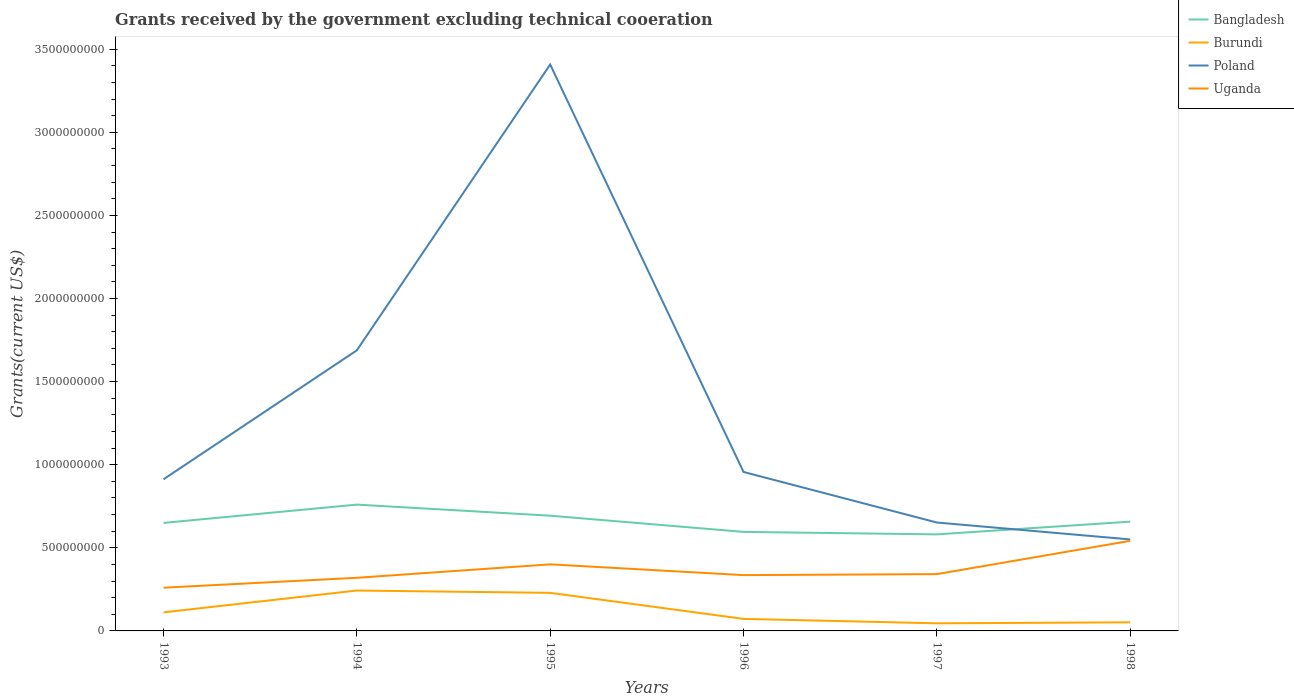Does the line corresponding to Burundi intersect with the line corresponding to Bangladesh?
Your answer should be compact. No. Is the number of lines equal to the number of legend labels?
Give a very brief answer. Yes. Across all years, what is the maximum total grants received by the government in Bangladesh?
Your answer should be very brief. 5.81e+08. What is the total total grants received by the government in Bangladesh in the graph?
Your answer should be very brief. 1.02e+08. What is the difference between the highest and the second highest total grants received by the government in Bangladesh?
Offer a terse response. 1.79e+08. How many years are there in the graph?
Offer a terse response. 6. What is the difference between two consecutive major ticks on the Y-axis?
Give a very brief answer. 5.00e+08. Are the values on the major ticks of Y-axis written in scientific E-notation?
Ensure brevity in your answer.  No. Does the graph contain grids?
Give a very brief answer. No. Where does the legend appear in the graph?
Offer a terse response. Top right. How are the legend labels stacked?
Your answer should be very brief. Vertical. What is the title of the graph?
Give a very brief answer. Grants received by the government excluding technical cooeration. Does "Grenada" appear as one of the legend labels in the graph?
Ensure brevity in your answer.  No. What is the label or title of the X-axis?
Offer a terse response. Years. What is the label or title of the Y-axis?
Make the answer very short. Grants(current US$). What is the Grants(current US$) in Bangladesh in 1993?
Your answer should be compact. 6.50e+08. What is the Grants(current US$) of Burundi in 1993?
Keep it short and to the point. 1.12e+08. What is the Grants(current US$) in Poland in 1993?
Provide a succinct answer. 9.12e+08. What is the Grants(current US$) in Uganda in 1993?
Keep it short and to the point. 2.60e+08. What is the Grants(current US$) in Bangladesh in 1994?
Provide a succinct answer. 7.60e+08. What is the Grants(current US$) of Burundi in 1994?
Your answer should be compact. 2.43e+08. What is the Grants(current US$) in Poland in 1994?
Provide a succinct answer. 1.69e+09. What is the Grants(current US$) in Uganda in 1994?
Your response must be concise. 3.20e+08. What is the Grants(current US$) of Bangladesh in 1995?
Offer a terse response. 6.93e+08. What is the Grants(current US$) of Burundi in 1995?
Offer a very short reply. 2.29e+08. What is the Grants(current US$) in Poland in 1995?
Keep it short and to the point. 3.41e+09. What is the Grants(current US$) in Uganda in 1995?
Your answer should be compact. 4.01e+08. What is the Grants(current US$) of Bangladesh in 1996?
Keep it short and to the point. 5.96e+08. What is the Grants(current US$) of Burundi in 1996?
Your answer should be compact. 7.24e+07. What is the Grants(current US$) in Poland in 1996?
Provide a succinct answer. 9.56e+08. What is the Grants(current US$) of Uganda in 1996?
Provide a short and direct response. 3.36e+08. What is the Grants(current US$) of Bangladesh in 1997?
Provide a succinct answer. 5.81e+08. What is the Grants(current US$) of Burundi in 1997?
Your answer should be very brief. 4.58e+07. What is the Grants(current US$) of Poland in 1997?
Offer a very short reply. 6.52e+08. What is the Grants(current US$) in Uganda in 1997?
Your answer should be compact. 3.42e+08. What is the Grants(current US$) of Bangladesh in 1998?
Offer a very short reply. 6.58e+08. What is the Grants(current US$) in Burundi in 1998?
Offer a terse response. 5.17e+07. What is the Grants(current US$) in Poland in 1998?
Keep it short and to the point. 5.50e+08. What is the Grants(current US$) in Uganda in 1998?
Provide a short and direct response. 5.42e+08. Across all years, what is the maximum Grants(current US$) of Bangladesh?
Your answer should be compact. 7.60e+08. Across all years, what is the maximum Grants(current US$) of Burundi?
Your answer should be very brief. 2.43e+08. Across all years, what is the maximum Grants(current US$) of Poland?
Ensure brevity in your answer.  3.41e+09. Across all years, what is the maximum Grants(current US$) in Uganda?
Your answer should be very brief. 5.42e+08. Across all years, what is the minimum Grants(current US$) of Bangladesh?
Your answer should be very brief. 5.81e+08. Across all years, what is the minimum Grants(current US$) of Burundi?
Offer a very short reply. 4.58e+07. Across all years, what is the minimum Grants(current US$) in Poland?
Your answer should be compact. 5.50e+08. Across all years, what is the minimum Grants(current US$) in Uganda?
Offer a very short reply. 2.60e+08. What is the total Grants(current US$) of Bangladesh in the graph?
Keep it short and to the point. 3.94e+09. What is the total Grants(current US$) of Burundi in the graph?
Offer a terse response. 7.54e+08. What is the total Grants(current US$) in Poland in the graph?
Keep it short and to the point. 8.17e+09. What is the total Grants(current US$) of Uganda in the graph?
Ensure brevity in your answer.  2.20e+09. What is the difference between the Grants(current US$) in Bangladesh in 1993 and that in 1994?
Offer a very short reply. -1.10e+08. What is the difference between the Grants(current US$) of Burundi in 1993 and that in 1994?
Your answer should be compact. -1.31e+08. What is the difference between the Grants(current US$) of Poland in 1993 and that in 1994?
Your answer should be very brief. -7.76e+08. What is the difference between the Grants(current US$) in Uganda in 1993 and that in 1994?
Offer a very short reply. -5.96e+07. What is the difference between the Grants(current US$) in Bangladesh in 1993 and that in 1995?
Keep it short and to the point. -4.34e+07. What is the difference between the Grants(current US$) in Burundi in 1993 and that in 1995?
Ensure brevity in your answer.  -1.17e+08. What is the difference between the Grants(current US$) in Poland in 1993 and that in 1995?
Your answer should be very brief. -2.50e+09. What is the difference between the Grants(current US$) of Uganda in 1993 and that in 1995?
Provide a short and direct response. -1.40e+08. What is the difference between the Grants(current US$) in Bangladesh in 1993 and that in 1996?
Your response must be concise. 5.40e+07. What is the difference between the Grants(current US$) of Burundi in 1993 and that in 1996?
Offer a very short reply. 3.93e+07. What is the difference between the Grants(current US$) in Poland in 1993 and that in 1996?
Offer a terse response. -4.42e+07. What is the difference between the Grants(current US$) in Uganda in 1993 and that in 1996?
Provide a succinct answer. -7.58e+07. What is the difference between the Grants(current US$) of Bangladesh in 1993 and that in 1997?
Your answer should be compact. 6.90e+07. What is the difference between the Grants(current US$) of Burundi in 1993 and that in 1997?
Provide a succinct answer. 6.59e+07. What is the difference between the Grants(current US$) of Poland in 1993 and that in 1997?
Your answer should be compact. 2.60e+08. What is the difference between the Grants(current US$) of Uganda in 1993 and that in 1997?
Give a very brief answer. -8.17e+07. What is the difference between the Grants(current US$) of Bangladesh in 1993 and that in 1998?
Ensure brevity in your answer.  -7.64e+06. What is the difference between the Grants(current US$) in Burundi in 1993 and that in 1998?
Make the answer very short. 6.00e+07. What is the difference between the Grants(current US$) in Poland in 1993 and that in 1998?
Provide a short and direct response. 3.62e+08. What is the difference between the Grants(current US$) in Uganda in 1993 and that in 1998?
Provide a short and direct response. -2.82e+08. What is the difference between the Grants(current US$) in Bangladesh in 1994 and that in 1995?
Provide a succinct answer. 6.66e+07. What is the difference between the Grants(current US$) in Burundi in 1994 and that in 1995?
Your answer should be compact. 1.40e+07. What is the difference between the Grants(current US$) in Poland in 1994 and that in 1995?
Offer a terse response. -1.72e+09. What is the difference between the Grants(current US$) in Uganda in 1994 and that in 1995?
Offer a very short reply. -8.09e+07. What is the difference between the Grants(current US$) in Bangladesh in 1994 and that in 1996?
Provide a succinct answer. 1.64e+08. What is the difference between the Grants(current US$) in Burundi in 1994 and that in 1996?
Your response must be concise. 1.71e+08. What is the difference between the Grants(current US$) in Poland in 1994 and that in 1996?
Provide a succinct answer. 7.32e+08. What is the difference between the Grants(current US$) of Uganda in 1994 and that in 1996?
Offer a terse response. -1.62e+07. What is the difference between the Grants(current US$) of Bangladesh in 1994 and that in 1997?
Give a very brief answer. 1.79e+08. What is the difference between the Grants(current US$) of Burundi in 1994 and that in 1997?
Offer a very short reply. 1.97e+08. What is the difference between the Grants(current US$) in Poland in 1994 and that in 1997?
Your answer should be very brief. 1.04e+09. What is the difference between the Grants(current US$) of Uganda in 1994 and that in 1997?
Make the answer very short. -2.21e+07. What is the difference between the Grants(current US$) in Bangladesh in 1994 and that in 1998?
Your answer should be compact. 1.02e+08. What is the difference between the Grants(current US$) of Burundi in 1994 and that in 1998?
Make the answer very short. 1.91e+08. What is the difference between the Grants(current US$) of Poland in 1994 and that in 1998?
Your response must be concise. 1.14e+09. What is the difference between the Grants(current US$) of Uganda in 1994 and that in 1998?
Keep it short and to the point. -2.22e+08. What is the difference between the Grants(current US$) in Bangladesh in 1995 and that in 1996?
Keep it short and to the point. 9.74e+07. What is the difference between the Grants(current US$) of Burundi in 1995 and that in 1996?
Offer a terse response. 1.57e+08. What is the difference between the Grants(current US$) of Poland in 1995 and that in 1996?
Your answer should be very brief. 2.45e+09. What is the difference between the Grants(current US$) of Uganda in 1995 and that in 1996?
Keep it short and to the point. 6.47e+07. What is the difference between the Grants(current US$) in Bangladesh in 1995 and that in 1997?
Your answer should be very brief. 1.12e+08. What is the difference between the Grants(current US$) in Burundi in 1995 and that in 1997?
Provide a short and direct response. 1.83e+08. What is the difference between the Grants(current US$) in Poland in 1995 and that in 1997?
Your answer should be compact. 2.76e+09. What is the difference between the Grants(current US$) of Uganda in 1995 and that in 1997?
Your answer should be compact. 5.88e+07. What is the difference between the Grants(current US$) in Bangladesh in 1995 and that in 1998?
Offer a terse response. 3.58e+07. What is the difference between the Grants(current US$) of Burundi in 1995 and that in 1998?
Offer a terse response. 1.77e+08. What is the difference between the Grants(current US$) of Poland in 1995 and that in 1998?
Your answer should be very brief. 2.86e+09. What is the difference between the Grants(current US$) of Uganda in 1995 and that in 1998?
Your answer should be compact. -1.42e+08. What is the difference between the Grants(current US$) of Bangladesh in 1996 and that in 1997?
Make the answer very short. 1.50e+07. What is the difference between the Grants(current US$) of Burundi in 1996 and that in 1997?
Provide a succinct answer. 2.66e+07. What is the difference between the Grants(current US$) in Poland in 1996 and that in 1997?
Your response must be concise. 3.04e+08. What is the difference between the Grants(current US$) in Uganda in 1996 and that in 1997?
Offer a very short reply. -5.92e+06. What is the difference between the Grants(current US$) of Bangladesh in 1996 and that in 1998?
Your response must be concise. -6.17e+07. What is the difference between the Grants(current US$) of Burundi in 1996 and that in 1998?
Offer a very short reply. 2.07e+07. What is the difference between the Grants(current US$) in Poland in 1996 and that in 1998?
Ensure brevity in your answer.  4.06e+08. What is the difference between the Grants(current US$) in Uganda in 1996 and that in 1998?
Keep it short and to the point. -2.06e+08. What is the difference between the Grants(current US$) of Bangladesh in 1997 and that in 1998?
Offer a terse response. -7.66e+07. What is the difference between the Grants(current US$) of Burundi in 1997 and that in 1998?
Your answer should be very brief. -5.87e+06. What is the difference between the Grants(current US$) in Poland in 1997 and that in 1998?
Give a very brief answer. 1.02e+08. What is the difference between the Grants(current US$) in Uganda in 1997 and that in 1998?
Provide a short and direct response. -2.00e+08. What is the difference between the Grants(current US$) of Bangladesh in 1993 and the Grants(current US$) of Burundi in 1994?
Ensure brevity in your answer.  4.07e+08. What is the difference between the Grants(current US$) of Bangladesh in 1993 and the Grants(current US$) of Poland in 1994?
Ensure brevity in your answer.  -1.04e+09. What is the difference between the Grants(current US$) in Bangladesh in 1993 and the Grants(current US$) in Uganda in 1994?
Keep it short and to the point. 3.30e+08. What is the difference between the Grants(current US$) of Burundi in 1993 and the Grants(current US$) of Poland in 1994?
Ensure brevity in your answer.  -1.58e+09. What is the difference between the Grants(current US$) of Burundi in 1993 and the Grants(current US$) of Uganda in 1994?
Your answer should be very brief. -2.08e+08. What is the difference between the Grants(current US$) of Poland in 1993 and the Grants(current US$) of Uganda in 1994?
Your answer should be very brief. 5.93e+08. What is the difference between the Grants(current US$) in Bangladesh in 1993 and the Grants(current US$) in Burundi in 1995?
Make the answer very short. 4.21e+08. What is the difference between the Grants(current US$) of Bangladesh in 1993 and the Grants(current US$) of Poland in 1995?
Provide a short and direct response. -2.76e+09. What is the difference between the Grants(current US$) of Bangladesh in 1993 and the Grants(current US$) of Uganda in 1995?
Your response must be concise. 2.49e+08. What is the difference between the Grants(current US$) of Burundi in 1993 and the Grants(current US$) of Poland in 1995?
Your response must be concise. -3.30e+09. What is the difference between the Grants(current US$) of Burundi in 1993 and the Grants(current US$) of Uganda in 1995?
Your answer should be compact. -2.89e+08. What is the difference between the Grants(current US$) in Poland in 1993 and the Grants(current US$) in Uganda in 1995?
Your answer should be compact. 5.12e+08. What is the difference between the Grants(current US$) in Bangladesh in 1993 and the Grants(current US$) in Burundi in 1996?
Offer a terse response. 5.78e+08. What is the difference between the Grants(current US$) in Bangladesh in 1993 and the Grants(current US$) in Poland in 1996?
Provide a short and direct response. -3.07e+08. What is the difference between the Grants(current US$) in Bangladesh in 1993 and the Grants(current US$) in Uganda in 1996?
Your response must be concise. 3.14e+08. What is the difference between the Grants(current US$) of Burundi in 1993 and the Grants(current US$) of Poland in 1996?
Your response must be concise. -8.45e+08. What is the difference between the Grants(current US$) of Burundi in 1993 and the Grants(current US$) of Uganda in 1996?
Give a very brief answer. -2.24e+08. What is the difference between the Grants(current US$) of Poland in 1993 and the Grants(current US$) of Uganda in 1996?
Provide a short and direct response. 5.76e+08. What is the difference between the Grants(current US$) of Bangladesh in 1993 and the Grants(current US$) of Burundi in 1997?
Provide a short and direct response. 6.04e+08. What is the difference between the Grants(current US$) in Bangladesh in 1993 and the Grants(current US$) in Poland in 1997?
Provide a short and direct response. -2.29e+06. What is the difference between the Grants(current US$) in Bangladesh in 1993 and the Grants(current US$) in Uganda in 1997?
Give a very brief answer. 3.08e+08. What is the difference between the Grants(current US$) in Burundi in 1993 and the Grants(current US$) in Poland in 1997?
Offer a very short reply. -5.40e+08. What is the difference between the Grants(current US$) of Burundi in 1993 and the Grants(current US$) of Uganda in 1997?
Offer a very short reply. -2.30e+08. What is the difference between the Grants(current US$) of Poland in 1993 and the Grants(current US$) of Uganda in 1997?
Your answer should be very brief. 5.70e+08. What is the difference between the Grants(current US$) in Bangladesh in 1993 and the Grants(current US$) in Burundi in 1998?
Provide a succinct answer. 5.98e+08. What is the difference between the Grants(current US$) in Bangladesh in 1993 and the Grants(current US$) in Poland in 1998?
Offer a terse response. 9.95e+07. What is the difference between the Grants(current US$) in Bangladesh in 1993 and the Grants(current US$) in Uganda in 1998?
Your answer should be compact. 1.08e+08. What is the difference between the Grants(current US$) in Burundi in 1993 and the Grants(current US$) in Poland in 1998?
Provide a succinct answer. -4.39e+08. What is the difference between the Grants(current US$) of Burundi in 1993 and the Grants(current US$) of Uganda in 1998?
Give a very brief answer. -4.30e+08. What is the difference between the Grants(current US$) in Poland in 1993 and the Grants(current US$) in Uganda in 1998?
Provide a succinct answer. 3.70e+08. What is the difference between the Grants(current US$) of Bangladesh in 1994 and the Grants(current US$) of Burundi in 1995?
Give a very brief answer. 5.31e+08. What is the difference between the Grants(current US$) of Bangladesh in 1994 and the Grants(current US$) of Poland in 1995?
Offer a very short reply. -2.65e+09. What is the difference between the Grants(current US$) of Bangladesh in 1994 and the Grants(current US$) of Uganda in 1995?
Your answer should be compact. 3.59e+08. What is the difference between the Grants(current US$) of Burundi in 1994 and the Grants(current US$) of Poland in 1995?
Offer a very short reply. -3.16e+09. What is the difference between the Grants(current US$) in Burundi in 1994 and the Grants(current US$) in Uganda in 1995?
Your response must be concise. -1.57e+08. What is the difference between the Grants(current US$) of Poland in 1994 and the Grants(current US$) of Uganda in 1995?
Make the answer very short. 1.29e+09. What is the difference between the Grants(current US$) in Bangladesh in 1994 and the Grants(current US$) in Burundi in 1996?
Your response must be concise. 6.88e+08. What is the difference between the Grants(current US$) of Bangladesh in 1994 and the Grants(current US$) of Poland in 1996?
Ensure brevity in your answer.  -1.96e+08. What is the difference between the Grants(current US$) of Bangladesh in 1994 and the Grants(current US$) of Uganda in 1996?
Keep it short and to the point. 4.24e+08. What is the difference between the Grants(current US$) in Burundi in 1994 and the Grants(current US$) in Poland in 1996?
Your response must be concise. -7.13e+08. What is the difference between the Grants(current US$) in Burundi in 1994 and the Grants(current US$) in Uganda in 1996?
Your answer should be compact. -9.28e+07. What is the difference between the Grants(current US$) in Poland in 1994 and the Grants(current US$) in Uganda in 1996?
Offer a terse response. 1.35e+09. What is the difference between the Grants(current US$) in Bangladesh in 1994 and the Grants(current US$) in Burundi in 1997?
Keep it short and to the point. 7.14e+08. What is the difference between the Grants(current US$) in Bangladesh in 1994 and the Grants(current US$) in Poland in 1997?
Your answer should be very brief. 1.08e+08. What is the difference between the Grants(current US$) in Bangladesh in 1994 and the Grants(current US$) in Uganda in 1997?
Provide a succinct answer. 4.18e+08. What is the difference between the Grants(current US$) in Burundi in 1994 and the Grants(current US$) in Poland in 1997?
Provide a short and direct response. -4.09e+08. What is the difference between the Grants(current US$) of Burundi in 1994 and the Grants(current US$) of Uganda in 1997?
Make the answer very short. -9.87e+07. What is the difference between the Grants(current US$) of Poland in 1994 and the Grants(current US$) of Uganda in 1997?
Make the answer very short. 1.35e+09. What is the difference between the Grants(current US$) of Bangladesh in 1994 and the Grants(current US$) of Burundi in 1998?
Your response must be concise. 7.08e+08. What is the difference between the Grants(current US$) in Bangladesh in 1994 and the Grants(current US$) in Poland in 1998?
Your answer should be very brief. 2.10e+08. What is the difference between the Grants(current US$) of Bangladesh in 1994 and the Grants(current US$) of Uganda in 1998?
Your answer should be very brief. 2.18e+08. What is the difference between the Grants(current US$) of Burundi in 1994 and the Grants(current US$) of Poland in 1998?
Keep it short and to the point. -3.07e+08. What is the difference between the Grants(current US$) in Burundi in 1994 and the Grants(current US$) in Uganda in 1998?
Your answer should be compact. -2.99e+08. What is the difference between the Grants(current US$) of Poland in 1994 and the Grants(current US$) of Uganda in 1998?
Give a very brief answer. 1.15e+09. What is the difference between the Grants(current US$) of Bangladesh in 1995 and the Grants(current US$) of Burundi in 1996?
Provide a short and direct response. 6.21e+08. What is the difference between the Grants(current US$) of Bangladesh in 1995 and the Grants(current US$) of Poland in 1996?
Ensure brevity in your answer.  -2.63e+08. What is the difference between the Grants(current US$) of Bangladesh in 1995 and the Grants(current US$) of Uganda in 1996?
Give a very brief answer. 3.57e+08. What is the difference between the Grants(current US$) in Burundi in 1995 and the Grants(current US$) in Poland in 1996?
Offer a terse response. -7.27e+08. What is the difference between the Grants(current US$) of Burundi in 1995 and the Grants(current US$) of Uganda in 1996?
Provide a short and direct response. -1.07e+08. What is the difference between the Grants(current US$) in Poland in 1995 and the Grants(current US$) in Uganda in 1996?
Ensure brevity in your answer.  3.07e+09. What is the difference between the Grants(current US$) in Bangladesh in 1995 and the Grants(current US$) in Burundi in 1997?
Provide a short and direct response. 6.47e+08. What is the difference between the Grants(current US$) in Bangladesh in 1995 and the Grants(current US$) in Poland in 1997?
Ensure brevity in your answer.  4.11e+07. What is the difference between the Grants(current US$) of Bangladesh in 1995 and the Grants(current US$) of Uganda in 1997?
Provide a short and direct response. 3.52e+08. What is the difference between the Grants(current US$) in Burundi in 1995 and the Grants(current US$) in Poland in 1997?
Make the answer very short. -4.23e+08. What is the difference between the Grants(current US$) of Burundi in 1995 and the Grants(current US$) of Uganda in 1997?
Offer a very short reply. -1.13e+08. What is the difference between the Grants(current US$) in Poland in 1995 and the Grants(current US$) in Uganda in 1997?
Ensure brevity in your answer.  3.07e+09. What is the difference between the Grants(current US$) in Bangladesh in 1995 and the Grants(current US$) in Burundi in 1998?
Give a very brief answer. 6.42e+08. What is the difference between the Grants(current US$) in Bangladesh in 1995 and the Grants(current US$) in Poland in 1998?
Your answer should be compact. 1.43e+08. What is the difference between the Grants(current US$) in Bangladesh in 1995 and the Grants(current US$) in Uganda in 1998?
Offer a terse response. 1.51e+08. What is the difference between the Grants(current US$) of Burundi in 1995 and the Grants(current US$) of Poland in 1998?
Your response must be concise. -3.21e+08. What is the difference between the Grants(current US$) in Burundi in 1995 and the Grants(current US$) in Uganda in 1998?
Provide a succinct answer. -3.13e+08. What is the difference between the Grants(current US$) in Poland in 1995 and the Grants(current US$) in Uganda in 1998?
Make the answer very short. 2.87e+09. What is the difference between the Grants(current US$) in Bangladesh in 1996 and the Grants(current US$) in Burundi in 1997?
Your answer should be very brief. 5.50e+08. What is the difference between the Grants(current US$) in Bangladesh in 1996 and the Grants(current US$) in Poland in 1997?
Give a very brief answer. -5.63e+07. What is the difference between the Grants(current US$) of Bangladesh in 1996 and the Grants(current US$) of Uganda in 1997?
Your answer should be very brief. 2.54e+08. What is the difference between the Grants(current US$) in Burundi in 1996 and the Grants(current US$) in Poland in 1997?
Ensure brevity in your answer.  -5.80e+08. What is the difference between the Grants(current US$) of Burundi in 1996 and the Grants(current US$) of Uganda in 1997?
Your answer should be compact. -2.69e+08. What is the difference between the Grants(current US$) in Poland in 1996 and the Grants(current US$) in Uganda in 1997?
Offer a terse response. 6.15e+08. What is the difference between the Grants(current US$) in Bangladesh in 1996 and the Grants(current US$) in Burundi in 1998?
Provide a succinct answer. 5.44e+08. What is the difference between the Grants(current US$) in Bangladesh in 1996 and the Grants(current US$) in Poland in 1998?
Offer a terse response. 4.54e+07. What is the difference between the Grants(current US$) of Bangladesh in 1996 and the Grants(current US$) of Uganda in 1998?
Provide a short and direct response. 5.38e+07. What is the difference between the Grants(current US$) in Burundi in 1996 and the Grants(current US$) in Poland in 1998?
Offer a very short reply. -4.78e+08. What is the difference between the Grants(current US$) in Burundi in 1996 and the Grants(current US$) in Uganda in 1998?
Give a very brief answer. -4.70e+08. What is the difference between the Grants(current US$) in Poland in 1996 and the Grants(current US$) in Uganda in 1998?
Offer a very short reply. 4.14e+08. What is the difference between the Grants(current US$) in Bangladesh in 1997 and the Grants(current US$) in Burundi in 1998?
Your answer should be compact. 5.29e+08. What is the difference between the Grants(current US$) in Bangladesh in 1997 and the Grants(current US$) in Poland in 1998?
Your answer should be very brief. 3.05e+07. What is the difference between the Grants(current US$) in Bangladesh in 1997 and the Grants(current US$) in Uganda in 1998?
Give a very brief answer. 3.88e+07. What is the difference between the Grants(current US$) of Burundi in 1997 and the Grants(current US$) of Poland in 1998?
Your answer should be compact. -5.05e+08. What is the difference between the Grants(current US$) of Burundi in 1997 and the Grants(current US$) of Uganda in 1998?
Offer a very short reply. -4.96e+08. What is the difference between the Grants(current US$) in Poland in 1997 and the Grants(current US$) in Uganda in 1998?
Offer a terse response. 1.10e+08. What is the average Grants(current US$) in Bangladesh per year?
Your answer should be very brief. 6.56e+08. What is the average Grants(current US$) in Burundi per year?
Offer a very short reply. 1.26e+08. What is the average Grants(current US$) in Poland per year?
Provide a short and direct response. 1.36e+09. What is the average Grants(current US$) of Uganda per year?
Provide a short and direct response. 3.67e+08. In the year 1993, what is the difference between the Grants(current US$) of Bangladesh and Grants(current US$) of Burundi?
Provide a short and direct response. 5.38e+08. In the year 1993, what is the difference between the Grants(current US$) in Bangladesh and Grants(current US$) in Poland?
Offer a terse response. -2.62e+08. In the year 1993, what is the difference between the Grants(current US$) in Bangladesh and Grants(current US$) in Uganda?
Offer a terse response. 3.90e+08. In the year 1993, what is the difference between the Grants(current US$) of Burundi and Grants(current US$) of Poland?
Offer a very short reply. -8.00e+08. In the year 1993, what is the difference between the Grants(current US$) of Burundi and Grants(current US$) of Uganda?
Your response must be concise. -1.48e+08. In the year 1993, what is the difference between the Grants(current US$) of Poland and Grants(current US$) of Uganda?
Your response must be concise. 6.52e+08. In the year 1994, what is the difference between the Grants(current US$) in Bangladesh and Grants(current US$) in Burundi?
Your response must be concise. 5.17e+08. In the year 1994, what is the difference between the Grants(current US$) in Bangladesh and Grants(current US$) in Poland?
Ensure brevity in your answer.  -9.28e+08. In the year 1994, what is the difference between the Grants(current US$) of Bangladesh and Grants(current US$) of Uganda?
Provide a short and direct response. 4.40e+08. In the year 1994, what is the difference between the Grants(current US$) of Burundi and Grants(current US$) of Poland?
Your response must be concise. -1.45e+09. In the year 1994, what is the difference between the Grants(current US$) of Burundi and Grants(current US$) of Uganda?
Your response must be concise. -7.66e+07. In the year 1994, what is the difference between the Grants(current US$) of Poland and Grants(current US$) of Uganda?
Give a very brief answer. 1.37e+09. In the year 1995, what is the difference between the Grants(current US$) in Bangladesh and Grants(current US$) in Burundi?
Offer a terse response. 4.64e+08. In the year 1995, what is the difference between the Grants(current US$) of Bangladesh and Grants(current US$) of Poland?
Provide a short and direct response. -2.71e+09. In the year 1995, what is the difference between the Grants(current US$) of Bangladesh and Grants(current US$) of Uganda?
Offer a very short reply. 2.93e+08. In the year 1995, what is the difference between the Grants(current US$) in Burundi and Grants(current US$) in Poland?
Offer a terse response. -3.18e+09. In the year 1995, what is the difference between the Grants(current US$) in Burundi and Grants(current US$) in Uganda?
Keep it short and to the point. -1.71e+08. In the year 1995, what is the difference between the Grants(current US$) of Poland and Grants(current US$) of Uganda?
Your response must be concise. 3.01e+09. In the year 1996, what is the difference between the Grants(current US$) of Bangladesh and Grants(current US$) of Burundi?
Your answer should be very brief. 5.23e+08. In the year 1996, what is the difference between the Grants(current US$) of Bangladesh and Grants(current US$) of Poland?
Keep it short and to the point. -3.61e+08. In the year 1996, what is the difference between the Grants(current US$) of Bangladesh and Grants(current US$) of Uganda?
Keep it short and to the point. 2.60e+08. In the year 1996, what is the difference between the Grants(current US$) in Burundi and Grants(current US$) in Poland?
Your answer should be compact. -8.84e+08. In the year 1996, what is the difference between the Grants(current US$) in Burundi and Grants(current US$) in Uganda?
Ensure brevity in your answer.  -2.63e+08. In the year 1996, what is the difference between the Grants(current US$) in Poland and Grants(current US$) in Uganda?
Make the answer very short. 6.21e+08. In the year 1997, what is the difference between the Grants(current US$) in Bangladesh and Grants(current US$) in Burundi?
Ensure brevity in your answer.  5.35e+08. In the year 1997, what is the difference between the Grants(current US$) of Bangladesh and Grants(current US$) of Poland?
Provide a succinct answer. -7.13e+07. In the year 1997, what is the difference between the Grants(current US$) of Bangladesh and Grants(current US$) of Uganda?
Give a very brief answer. 2.39e+08. In the year 1997, what is the difference between the Grants(current US$) of Burundi and Grants(current US$) of Poland?
Your response must be concise. -6.06e+08. In the year 1997, what is the difference between the Grants(current US$) in Burundi and Grants(current US$) in Uganda?
Keep it short and to the point. -2.96e+08. In the year 1997, what is the difference between the Grants(current US$) of Poland and Grants(current US$) of Uganda?
Provide a succinct answer. 3.10e+08. In the year 1998, what is the difference between the Grants(current US$) of Bangladesh and Grants(current US$) of Burundi?
Give a very brief answer. 6.06e+08. In the year 1998, what is the difference between the Grants(current US$) of Bangladesh and Grants(current US$) of Poland?
Provide a succinct answer. 1.07e+08. In the year 1998, what is the difference between the Grants(current US$) of Bangladesh and Grants(current US$) of Uganda?
Keep it short and to the point. 1.15e+08. In the year 1998, what is the difference between the Grants(current US$) in Burundi and Grants(current US$) in Poland?
Keep it short and to the point. -4.99e+08. In the year 1998, what is the difference between the Grants(current US$) of Burundi and Grants(current US$) of Uganda?
Your answer should be compact. -4.90e+08. In the year 1998, what is the difference between the Grants(current US$) of Poland and Grants(current US$) of Uganda?
Provide a succinct answer. 8.35e+06. What is the ratio of the Grants(current US$) of Bangladesh in 1993 to that in 1994?
Keep it short and to the point. 0.86. What is the ratio of the Grants(current US$) in Burundi in 1993 to that in 1994?
Offer a terse response. 0.46. What is the ratio of the Grants(current US$) in Poland in 1993 to that in 1994?
Ensure brevity in your answer.  0.54. What is the ratio of the Grants(current US$) in Uganda in 1993 to that in 1994?
Offer a terse response. 0.81. What is the ratio of the Grants(current US$) of Bangladesh in 1993 to that in 1995?
Make the answer very short. 0.94. What is the ratio of the Grants(current US$) in Burundi in 1993 to that in 1995?
Give a very brief answer. 0.49. What is the ratio of the Grants(current US$) in Poland in 1993 to that in 1995?
Offer a very short reply. 0.27. What is the ratio of the Grants(current US$) of Uganda in 1993 to that in 1995?
Give a very brief answer. 0.65. What is the ratio of the Grants(current US$) of Bangladesh in 1993 to that in 1996?
Give a very brief answer. 1.09. What is the ratio of the Grants(current US$) in Burundi in 1993 to that in 1996?
Ensure brevity in your answer.  1.54. What is the ratio of the Grants(current US$) of Poland in 1993 to that in 1996?
Give a very brief answer. 0.95. What is the ratio of the Grants(current US$) in Uganda in 1993 to that in 1996?
Keep it short and to the point. 0.77. What is the ratio of the Grants(current US$) of Bangladesh in 1993 to that in 1997?
Give a very brief answer. 1.12. What is the ratio of the Grants(current US$) of Burundi in 1993 to that in 1997?
Your answer should be very brief. 2.44. What is the ratio of the Grants(current US$) in Poland in 1993 to that in 1997?
Make the answer very short. 1.4. What is the ratio of the Grants(current US$) of Uganda in 1993 to that in 1997?
Offer a terse response. 0.76. What is the ratio of the Grants(current US$) in Bangladesh in 1993 to that in 1998?
Offer a very short reply. 0.99. What is the ratio of the Grants(current US$) of Burundi in 1993 to that in 1998?
Offer a very short reply. 2.16. What is the ratio of the Grants(current US$) in Poland in 1993 to that in 1998?
Offer a terse response. 1.66. What is the ratio of the Grants(current US$) in Uganda in 1993 to that in 1998?
Keep it short and to the point. 0.48. What is the ratio of the Grants(current US$) in Bangladesh in 1994 to that in 1995?
Your response must be concise. 1.1. What is the ratio of the Grants(current US$) in Burundi in 1994 to that in 1995?
Offer a terse response. 1.06. What is the ratio of the Grants(current US$) in Poland in 1994 to that in 1995?
Ensure brevity in your answer.  0.5. What is the ratio of the Grants(current US$) in Uganda in 1994 to that in 1995?
Offer a terse response. 0.8. What is the ratio of the Grants(current US$) of Bangladesh in 1994 to that in 1996?
Your answer should be very brief. 1.28. What is the ratio of the Grants(current US$) of Burundi in 1994 to that in 1996?
Keep it short and to the point. 3.36. What is the ratio of the Grants(current US$) of Poland in 1994 to that in 1996?
Your answer should be compact. 1.77. What is the ratio of the Grants(current US$) of Uganda in 1994 to that in 1996?
Offer a very short reply. 0.95. What is the ratio of the Grants(current US$) in Bangladesh in 1994 to that in 1997?
Provide a short and direct response. 1.31. What is the ratio of the Grants(current US$) in Burundi in 1994 to that in 1997?
Your answer should be compact. 5.31. What is the ratio of the Grants(current US$) in Poland in 1994 to that in 1997?
Your response must be concise. 2.59. What is the ratio of the Grants(current US$) of Uganda in 1994 to that in 1997?
Your answer should be compact. 0.94. What is the ratio of the Grants(current US$) of Bangladesh in 1994 to that in 1998?
Your response must be concise. 1.16. What is the ratio of the Grants(current US$) in Burundi in 1994 to that in 1998?
Keep it short and to the point. 4.7. What is the ratio of the Grants(current US$) of Poland in 1994 to that in 1998?
Offer a terse response. 3.07. What is the ratio of the Grants(current US$) in Uganda in 1994 to that in 1998?
Your response must be concise. 0.59. What is the ratio of the Grants(current US$) in Bangladesh in 1995 to that in 1996?
Provide a succinct answer. 1.16. What is the ratio of the Grants(current US$) of Burundi in 1995 to that in 1996?
Ensure brevity in your answer.  3.17. What is the ratio of the Grants(current US$) in Poland in 1995 to that in 1996?
Give a very brief answer. 3.56. What is the ratio of the Grants(current US$) of Uganda in 1995 to that in 1996?
Make the answer very short. 1.19. What is the ratio of the Grants(current US$) in Bangladesh in 1995 to that in 1997?
Your response must be concise. 1.19. What is the ratio of the Grants(current US$) in Burundi in 1995 to that in 1997?
Your answer should be compact. 5. What is the ratio of the Grants(current US$) in Poland in 1995 to that in 1997?
Ensure brevity in your answer.  5.23. What is the ratio of the Grants(current US$) in Uganda in 1995 to that in 1997?
Provide a succinct answer. 1.17. What is the ratio of the Grants(current US$) in Bangladesh in 1995 to that in 1998?
Your answer should be very brief. 1.05. What is the ratio of the Grants(current US$) in Burundi in 1995 to that in 1998?
Keep it short and to the point. 4.43. What is the ratio of the Grants(current US$) in Poland in 1995 to that in 1998?
Make the answer very short. 6.19. What is the ratio of the Grants(current US$) in Uganda in 1995 to that in 1998?
Offer a terse response. 0.74. What is the ratio of the Grants(current US$) of Bangladesh in 1996 to that in 1997?
Provide a succinct answer. 1.03. What is the ratio of the Grants(current US$) in Burundi in 1996 to that in 1997?
Your answer should be compact. 1.58. What is the ratio of the Grants(current US$) in Poland in 1996 to that in 1997?
Give a very brief answer. 1.47. What is the ratio of the Grants(current US$) in Uganda in 1996 to that in 1997?
Provide a short and direct response. 0.98. What is the ratio of the Grants(current US$) in Bangladesh in 1996 to that in 1998?
Offer a terse response. 0.91. What is the ratio of the Grants(current US$) in Burundi in 1996 to that in 1998?
Provide a succinct answer. 1.4. What is the ratio of the Grants(current US$) in Poland in 1996 to that in 1998?
Your answer should be compact. 1.74. What is the ratio of the Grants(current US$) in Uganda in 1996 to that in 1998?
Offer a very short reply. 0.62. What is the ratio of the Grants(current US$) of Bangladesh in 1997 to that in 1998?
Keep it short and to the point. 0.88. What is the ratio of the Grants(current US$) in Burundi in 1997 to that in 1998?
Provide a short and direct response. 0.89. What is the ratio of the Grants(current US$) of Poland in 1997 to that in 1998?
Your answer should be compact. 1.18. What is the ratio of the Grants(current US$) of Uganda in 1997 to that in 1998?
Ensure brevity in your answer.  0.63. What is the difference between the highest and the second highest Grants(current US$) of Bangladesh?
Your answer should be very brief. 6.66e+07. What is the difference between the highest and the second highest Grants(current US$) in Burundi?
Offer a very short reply. 1.40e+07. What is the difference between the highest and the second highest Grants(current US$) of Poland?
Give a very brief answer. 1.72e+09. What is the difference between the highest and the second highest Grants(current US$) of Uganda?
Ensure brevity in your answer.  1.42e+08. What is the difference between the highest and the lowest Grants(current US$) in Bangladesh?
Give a very brief answer. 1.79e+08. What is the difference between the highest and the lowest Grants(current US$) of Burundi?
Provide a succinct answer. 1.97e+08. What is the difference between the highest and the lowest Grants(current US$) in Poland?
Your response must be concise. 2.86e+09. What is the difference between the highest and the lowest Grants(current US$) of Uganda?
Keep it short and to the point. 2.82e+08. 